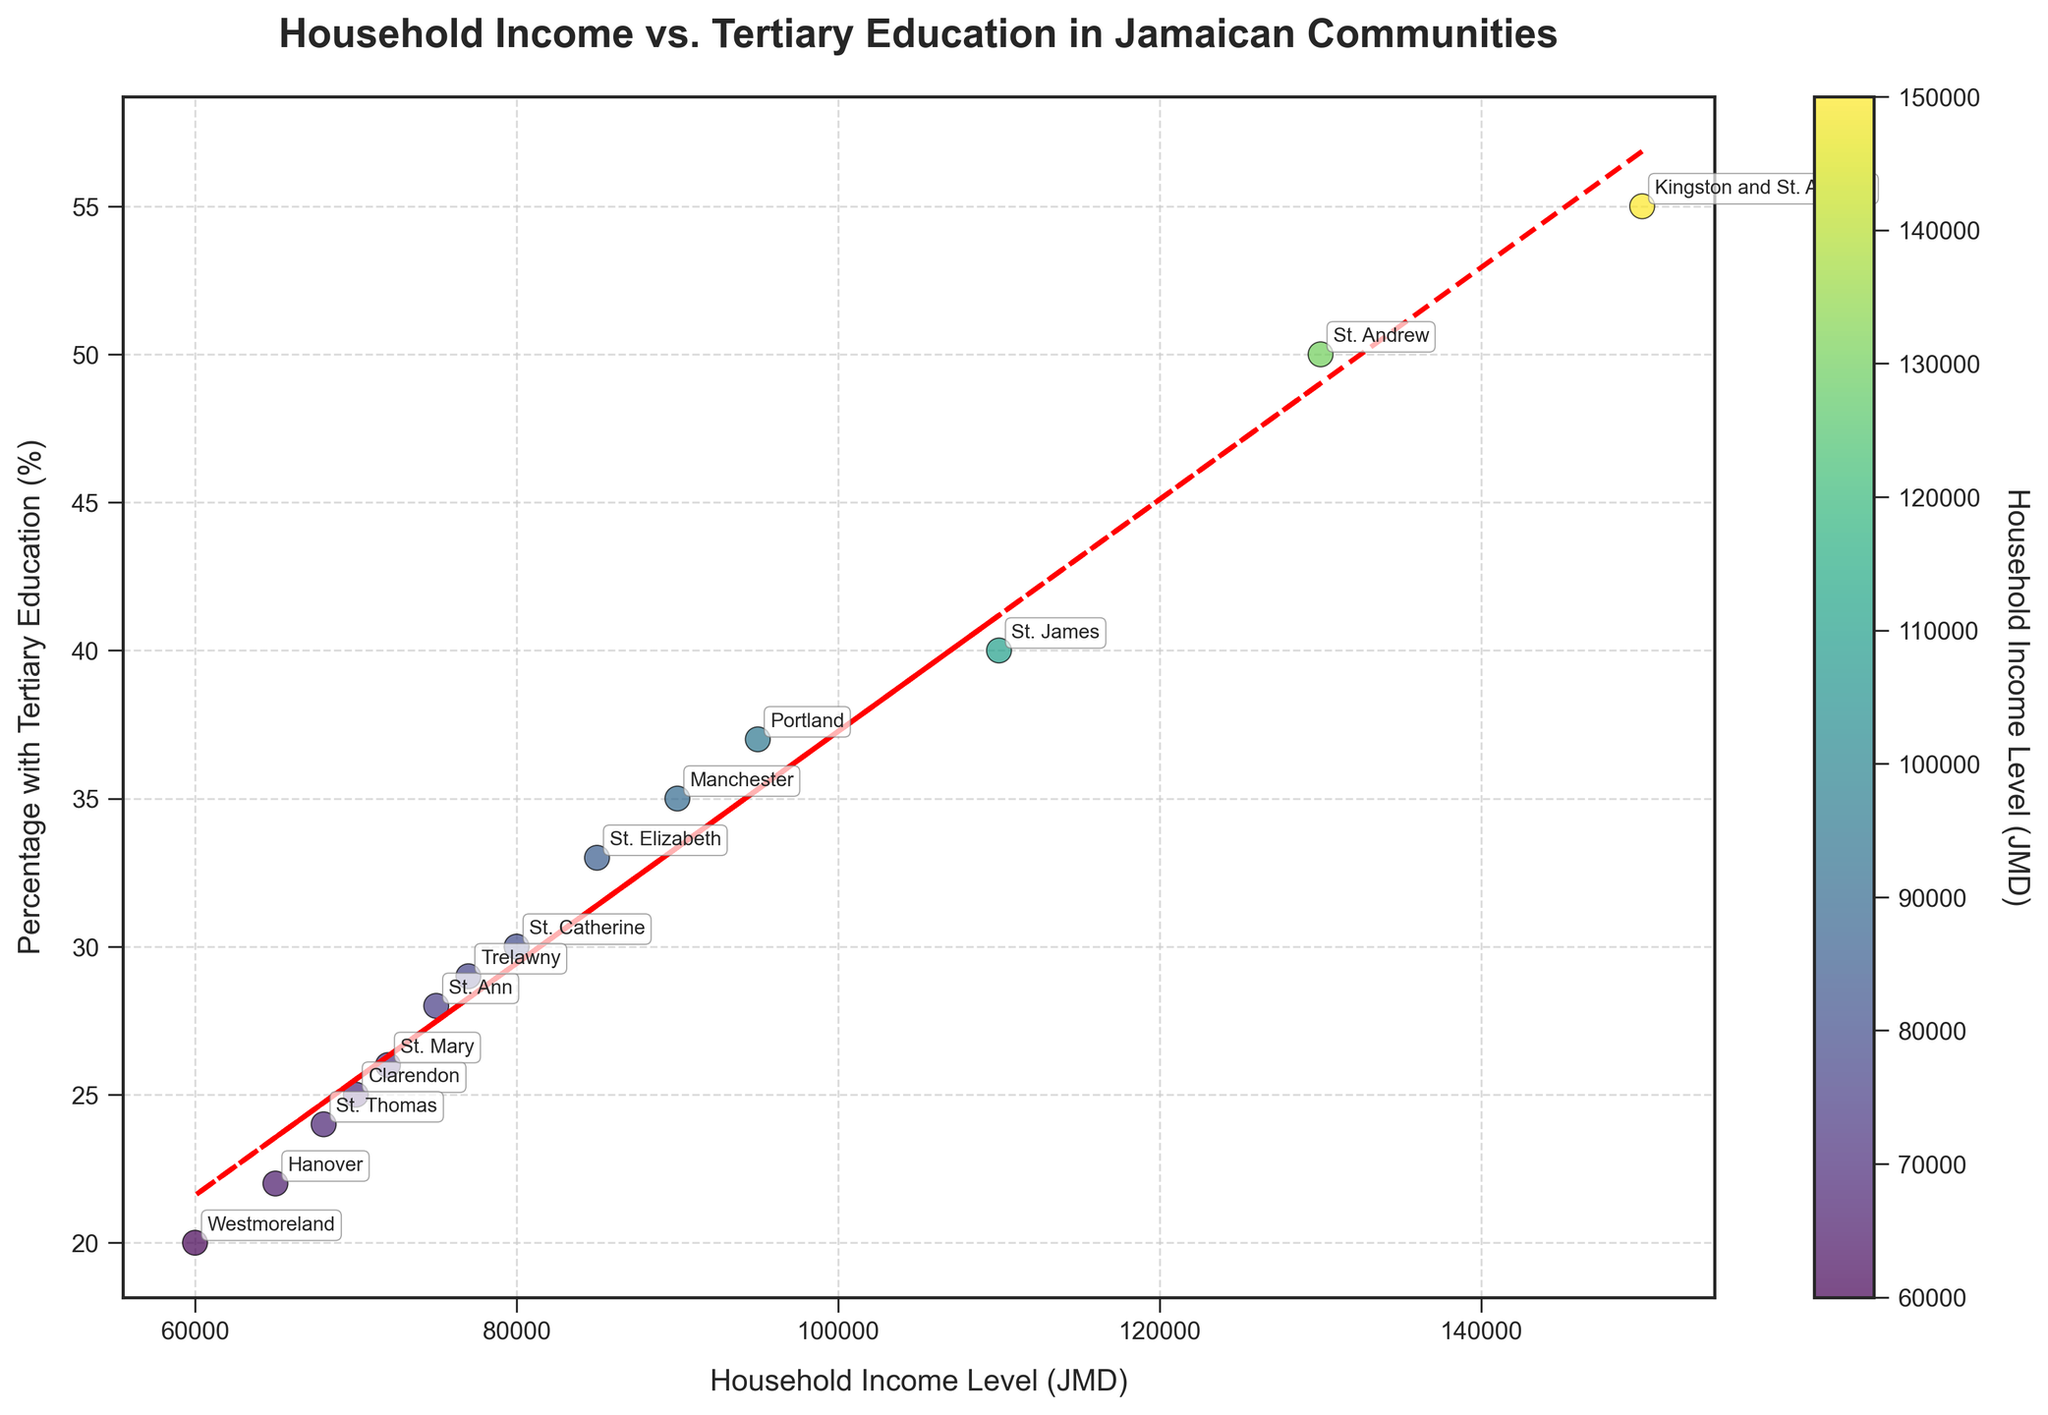What is the title of the plot? The title of the plot is displayed at the top and summarizes what is shown in the figure.
Answer: Household Income vs. Tertiary Education in Jamaican Communities Which community has the highest household income level? By looking at the x-axis, we can see the community with the highest value. This is also highlighted with annotations.
Answer: Kingston and St. Andrew What is the percentage with tertiary education for St. James? Locate the point labeled "St. James" and check its position on the y-axis.
Answer: 40% How many communities have a household income level between 60,000 JMD and 90,000 JMD? Count the data points along the x-axis within the specified range, using the annotations for guidance.
Answer: 7 What is the trend of the relationship between household income level and percentage with tertiary education? The trend line, which is a red dashed line, shows a positive slope, indicating a positive relationship.
Answer: Positive Which community has the lowest percentage with tertiary education? Look at the y-axis for the lowest value and find the corresponding community annotation.
Answer: Westmoreland Compare the household income levels of St. Catherine and Manchester. Which one is higher? Find the points for St. Catherine and Manchester and compare their positions on the x-axis.
Answer: Manchester What is the average household income of the communities shown in the plot? Add all the household income levels and divide by the number of communities. \( \frac{150000 + 80000 + 70000 + 90000 + 110000 + 75000 + 60000 + 85000 + 95000 + 72000 + 65000 + 68000 + 77000 + 130000}{14} = 87285.71 \)
Answer: 87,285.71 JMD Does the trend line indicate that communities with higher household incomes generally have higher percentages with tertiary education? The trend line slope is positive, suggesting communities with higher incomes tend to have a higher percentage with tertiary education.
Answer: Yes Which community is an outlier if we consider both household income levels and percentage with tertiary education? An outlier would be significantly distant from the trend line. Kingston and St. Andrew stands out due to its high household income and a high percentage with tertiary education.
Answer: Kingston and St. Andrew 